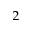<formula> <loc_0><loc_0><loc_500><loc_500>_ { 2 }</formula> 